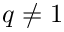Convert formula to latex. <formula><loc_0><loc_0><loc_500><loc_500>q \not = 1</formula> 